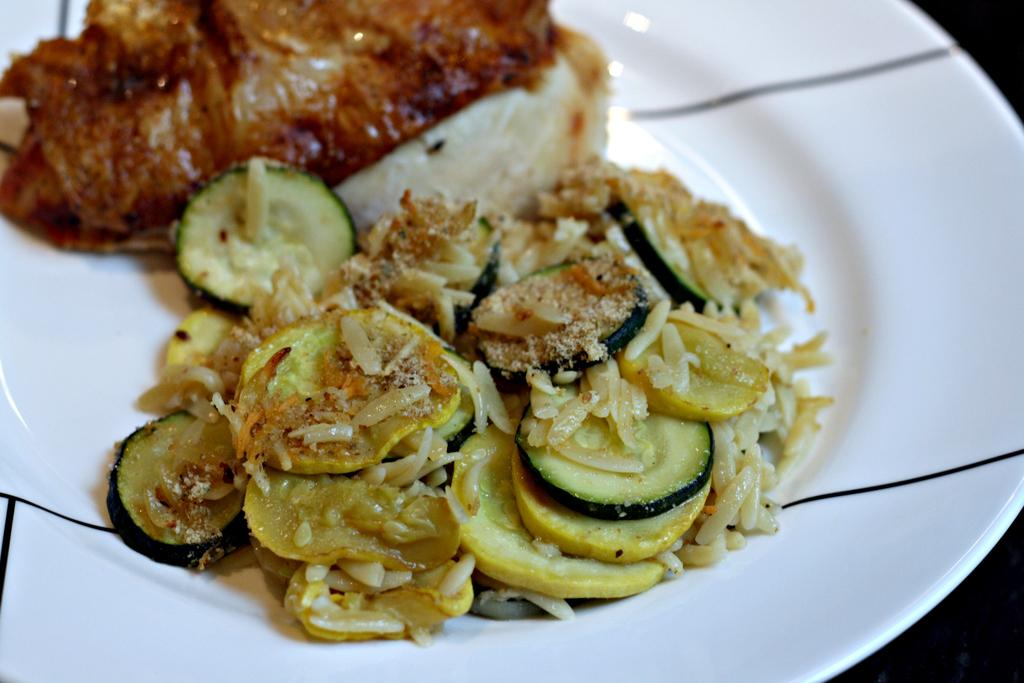What can be seen on the plate in the image? There is food on the plate in the image. Can you describe the plate itself? The facts provided do not give any details about the plate, so we cannot describe it further. What invention is being used to transport the food on the plate in the image? There is no invention visible in the image; the food is simply on the plate. 